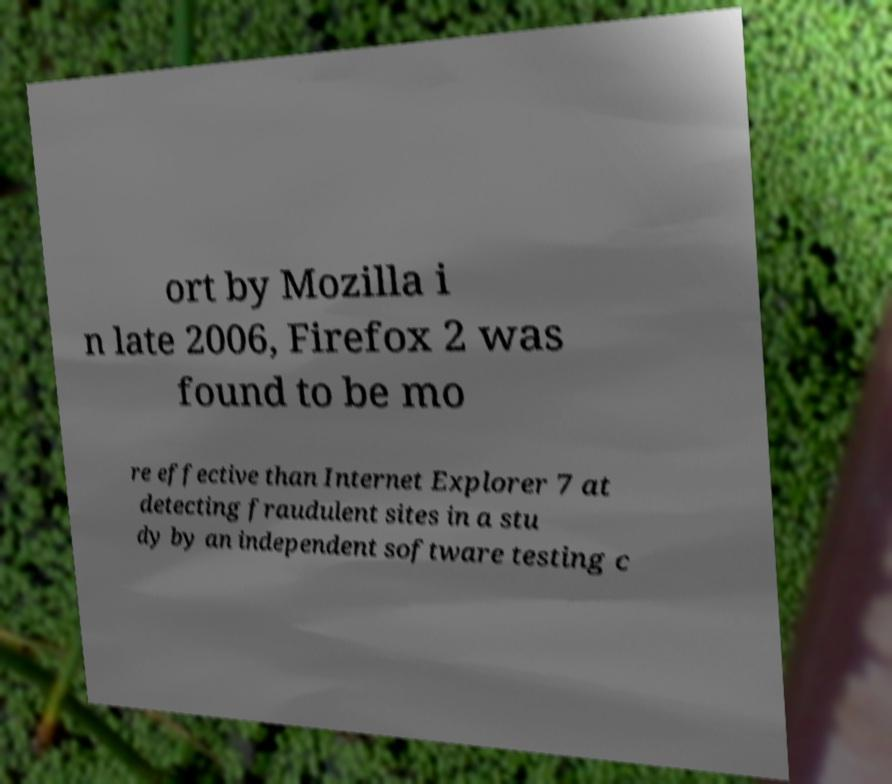Please read and relay the text visible in this image. What does it say? ort by Mozilla i n late 2006, Firefox 2 was found to be mo re effective than Internet Explorer 7 at detecting fraudulent sites in a stu dy by an independent software testing c 